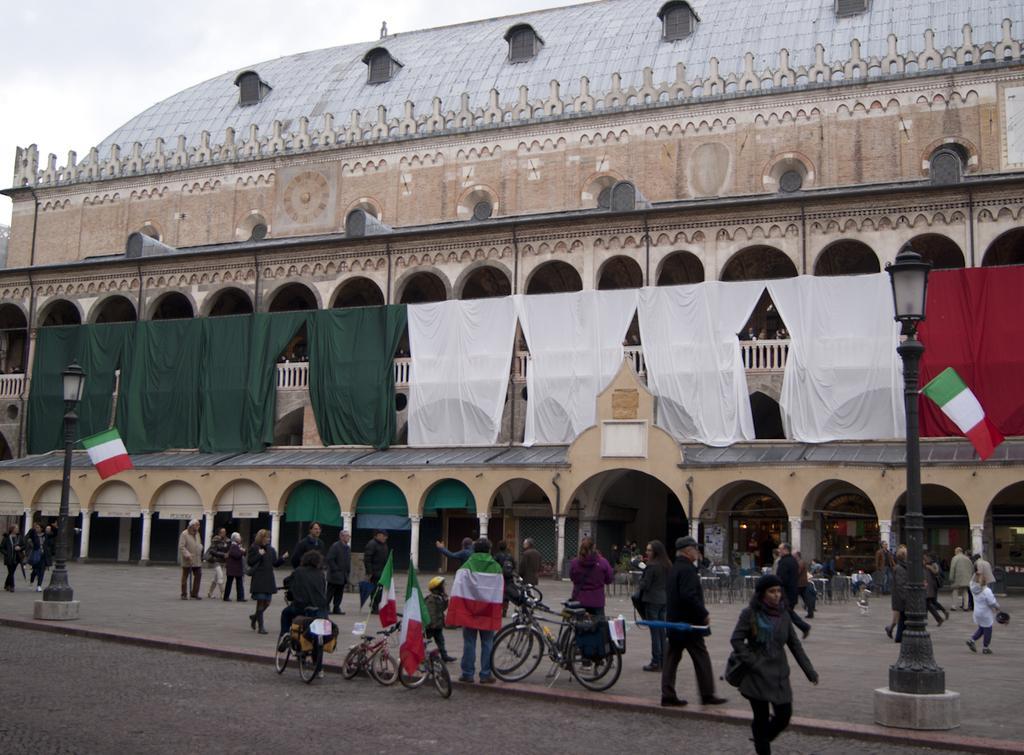Can you describe this image briefly? At the bottom of the image there are few bicycles. There is a person sitting on the bicycle and also there are few bicycles with flags. There is a person standing and wearing a flag on him. There are poles with lamps and flags. There are many people walking on the floor. And also there are tables. In the image there is a building with arches, clothes, windows, pillars, walls and roof. At the top of the image there is sky. 